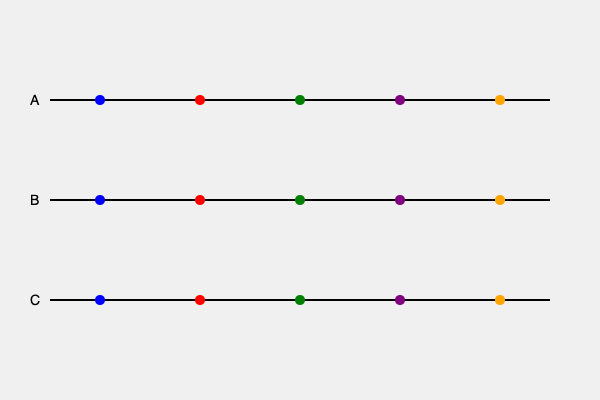Analyze the three timelines (A, B, and C) representing different narrative structures in a film. Which cognitive theory best explains the increased mental effort required to process timeline B compared to timeline A, and how might this impact the viewer's comprehension and engagement with the story? To answer this question, we need to consider several cognitive theories and their application to narrative processing:

1. Chronological order: Timeline A presents events in a linear, chronological order (left to right), which aligns with our natural tendency to process information sequentially.

2. Non-linear structure: Timeline B presents events in a non-linear order, requiring more cognitive resources to process and understand the narrative.

3. Cognitive Load Theory: This theory suggests that our working memory has limited capacity. The non-linear structure of Timeline B increases cognitive load as viewers must hold and manipulate more information simultaneously.

4. Schema Theory: Our minds use existing schemas (mental frameworks) to understand new information. Timeline A fits better with our typical schema for story progression, while Timeline B challenges this schema.

5. Event Segmentation Theory: This theory proposes that we naturally segment continuous experiences into discrete events. The non-linear structure of Timeline B disrupts this natural segmentation process.

6. Narrative Transportation Theory: This theory suggests that immersion in a story depends on the ease with which we can construct a mental model of the narrative world. The non-linear structure of Timeline B may impede this process.

Given these considerations, the cognitive theory that best explains the increased mental effort required to process Timeline B is Cognitive Load Theory. The non-linear structure increases the cognitive load on working memory, as viewers must:

a) Remember events out of chronological order
b) Mentally reorganize events to understand causal relationships
c) Maintain multiple narrative threads simultaneously

This increased cognitive load may impact viewer comprehension and engagement in the following ways:

1. Initial confusion: Viewers may struggle to follow the story initially, potentially leading to disengagement.
2. Deeper processing: The additional cognitive effort required may lead to more elaborate processing and potentially better long-term retention of the story.
3. Emotional distance: The cognitive demands may temporarily reduce emotional engagement as viewers focus on understanding the narrative structure.
4. Increased attention: The novelty of the non-linear structure may increase overall attention to the film.
5. Satisfaction upon resolution: Successfully "solving" the narrative puzzle may lead to increased satisfaction and engagement.
Answer: Cognitive Load Theory 